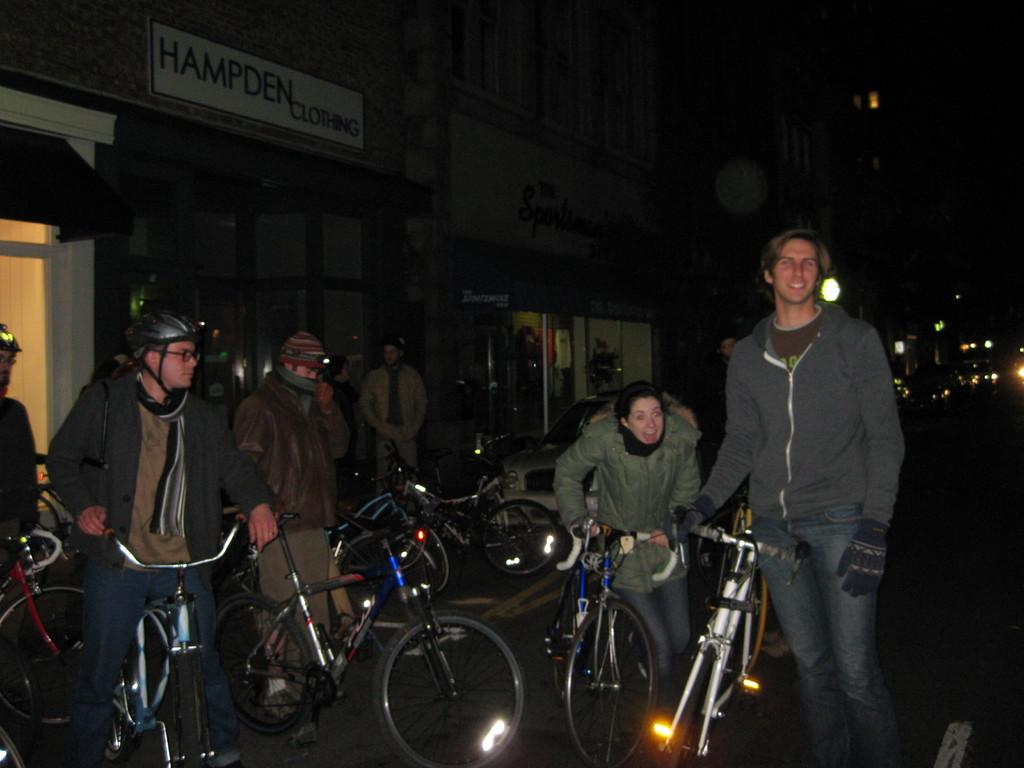What is the main object in the image? There is a board in the image. What can be observed about the background of the image? The background of the image is dark. What are the people in the image doing? The persons are standing in the image and holding a bicycle. How are they holding the bicycle? The bicycle is being held with their hands. What is visible in the image besides the board and people? There is a road visible in the image. How many brothers are visible in the image? There is no mention of brothers in the image; it features persons holding a bicycle. What color is the sock on the person's right foot? There is no mention of socks or feet in the image; it only shows persons holding a bicycle. 